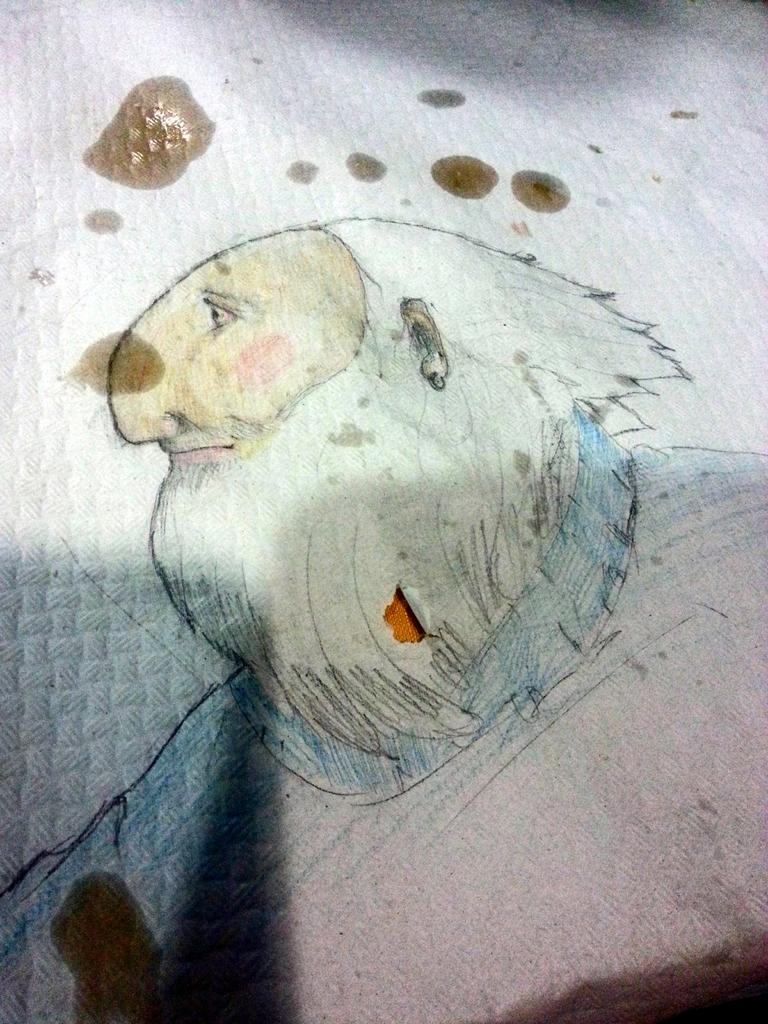What is depicted in the image? There is a sketch in the image. What else can be seen in the image besides the sketch? There are oil drops on the cloth in the image. What type of canvas is the snail using to create the sketch in the image? There is no snail or canvas present in the image; it features a sketch and oil drops on a cloth. What type of fuel is being used to power the sketch in the image? There is no fuel or indication of a power source in the image; it features a sketch and oil drops on a cloth. 